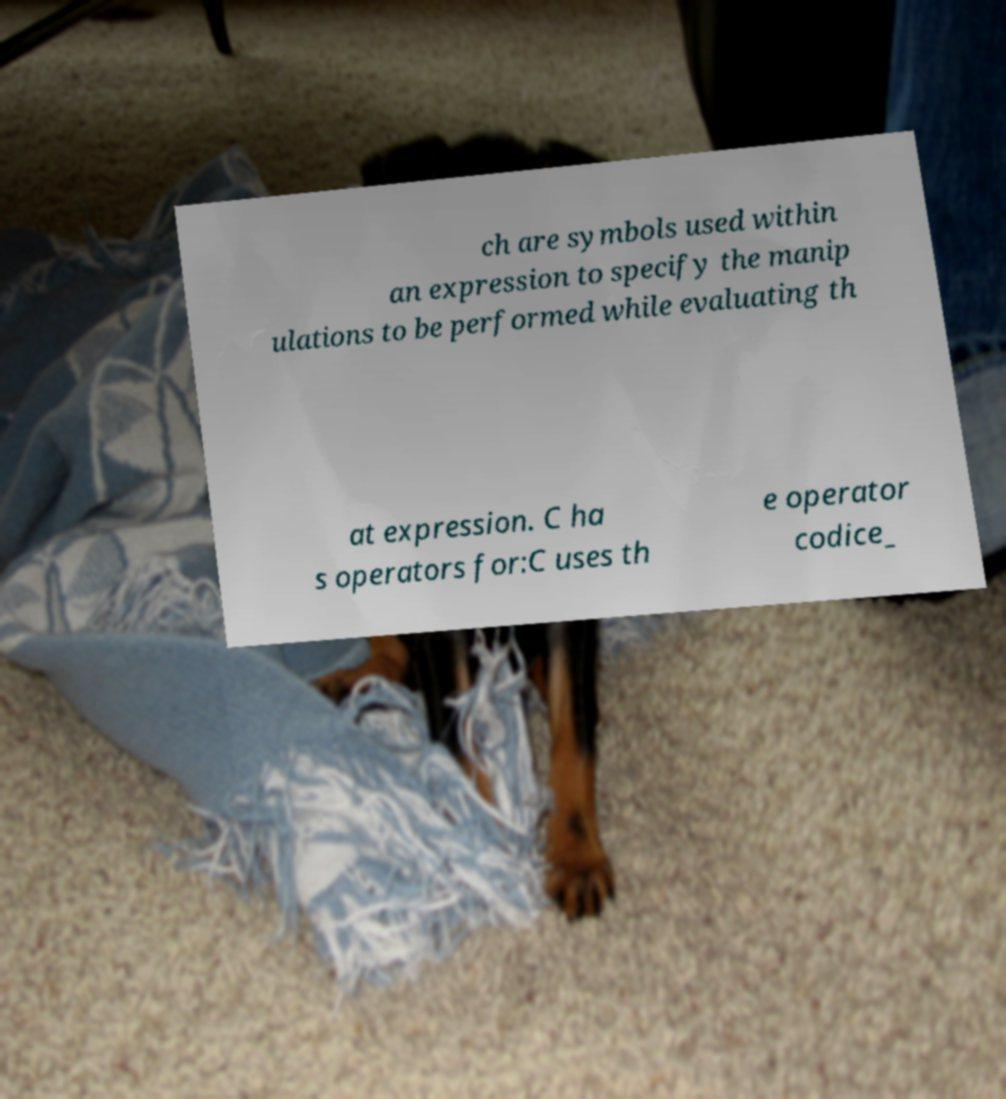There's text embedded in this image that I need extracted. Can you transcribe it verbatim? ch are symbols used within an expression to specify the manip ulations to be performed while evaluating th at expression. C ha s operators for:C uses th e operator codice_ 